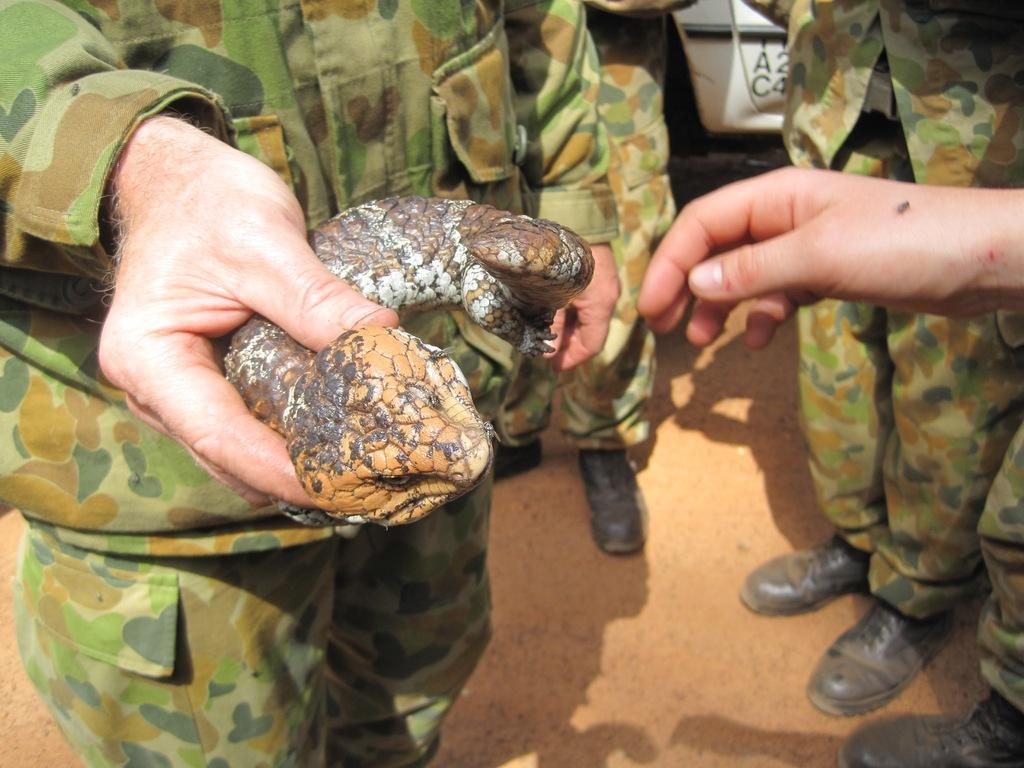How many people are in the image? There is a group of people in the image. What is the man on the left side of the image holding? The man is holding a reptile in his hand. Can you describe the position of the man in the image? The man is on the left side of the image. What type of seed is the man planting in the image? There is no seed present in the image; the man is holding a reptile. 